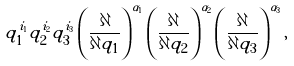Convert formula to latex. <formula><loc_0><loc_0><loc_500><loc_500>q _ { 1 } ^ { i _ { 1 } } q _ { 2 } ^ { i _ { 2 } } q _ { 3 } ^ { i _ { 3 } } \left ( \frac { \partial } { \partial q _ { 1 } } \right ) ^ { \alpha _ { 1 } } \left ( \frac { \partial } { \partial q _ { 2 } } \right ) ^ { \alpha _ { 2 } } \left ( \frac { \partial } { \partial q _ { 3 } } \right ) ^ { \alpha _ { 3 } } ,</formula> 